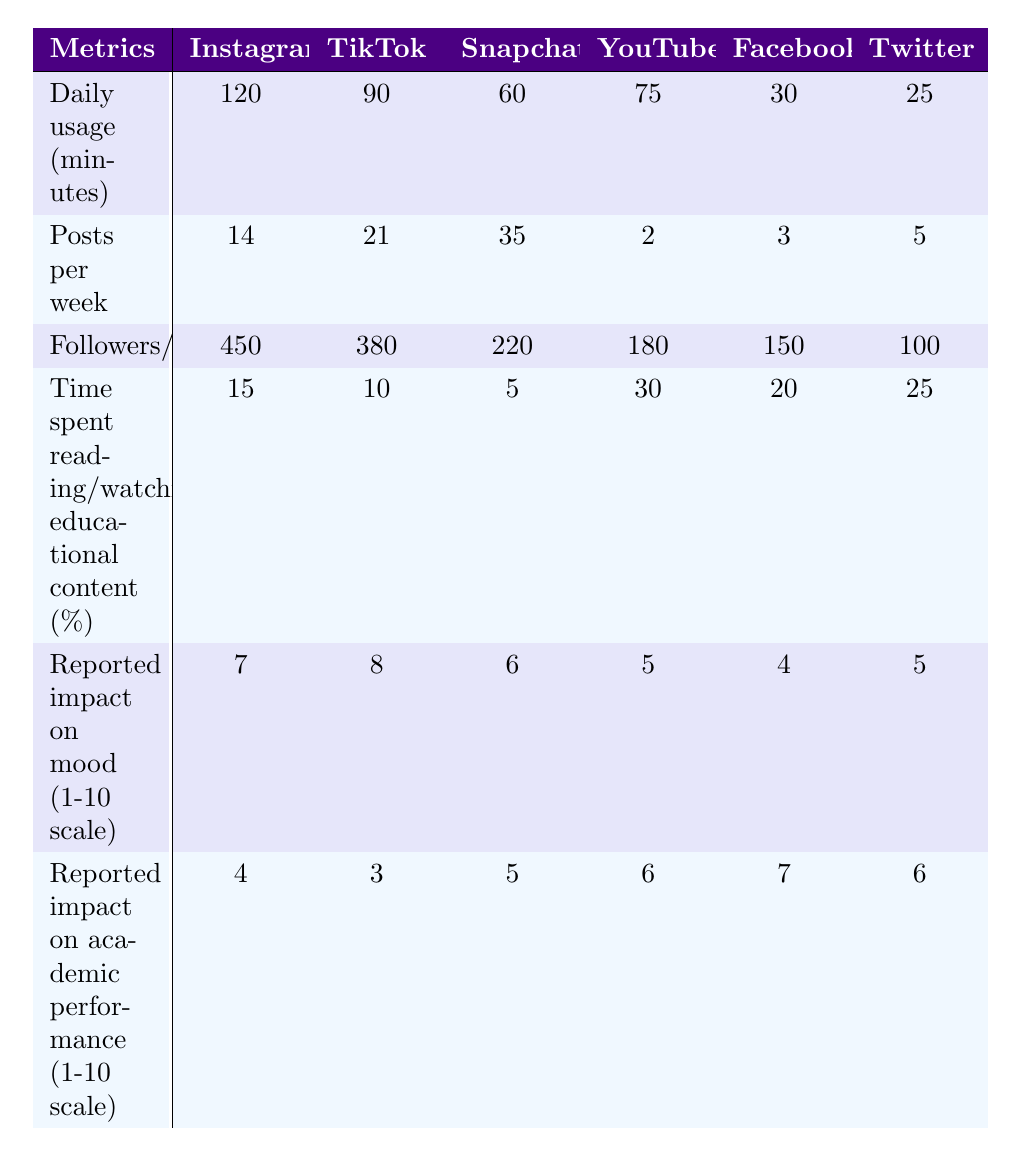What is the daily usage time in minutes for Snapchat? The table shows the daily usage times for each platform listed. For Snapchat, the daily usage is specifically given as 60 minutes.
Answer: 60 minutes Which platform has the highest number of followers or subscribers? Looking across the row for "Followers/subscribers", Instagram has 450, which is the highest compared to other platforms: TikTok (380), Snapchat (220), etc.
Answer: Instagram What is the average reported impact on mood from all platforms? To calculate the average, we sum the impact values: (7 + 8 + 6 + 5 + 4 + 5) = 35, then divide by the number of platforms, which is 6. So, 35/6 = approximately 5.83.
Answer: 5.83 Is the time spent reading or watching educational content highest for YouTube? In the "Time spent reading/watching educational content (%)" row, YouTube is listed at 30%, which is the highest value compared to the others.
Answer: Yes What is the difference in daily usage time between Instagram and Twitter? Instagram shows a daily usage time of 120 minutes, while Twitter shows 25 minutes. The difference is calculated as 120 - 25 = 95 minutes.
Answer: 95 minutes Which platform has the lowest impact on academic performance? By checking the "Reported impact on academic performance" row, Facebook has the lowest score at 7, compared to the other platforms.
Answer: Facebook How many more posts per week do Snapchat users make compared to YouTube users? From the "Posts per week" row, Snapchat has 35 posts per week, while YouTube has only 2. The difference is 35 - 2 = 33 posts per week.
Answer: 33 posts Which platform has the highest percentage of time spent on educational content? The maximum value in the "Time spent reading/watching educational content (%)" row is found to be 30% for YouTube.
Answer: YouTube If a student spends an equal amount of time on Instagram and TikTok, how many total minutes would they spend daily? For Instagram, the daily usage is 120 minutes, and for TikTok, it is 90 minutes. Adding these gives 120 + 90 = 210 minutes total.
Answer: 210 minutes Which platforms have a reported mood impact of 6 or higher? Checking the "Reported impact on mood" values, the platforms with scores of 6 or higher are Instagram (7), TikTok (8), Snapchat (6), and Twitter (5). So, Instagram, TikTok, and Snapchat.
Answer: Instagram, TikTok, Snapchat 